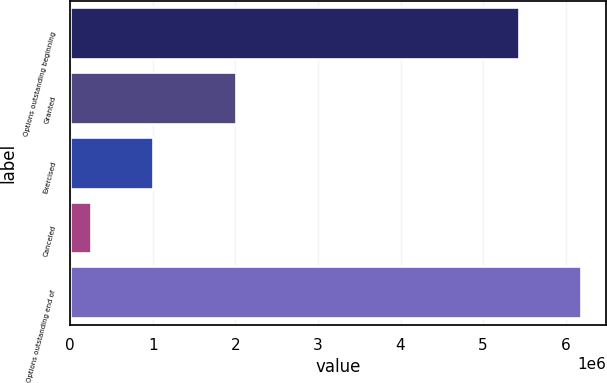Convert chart. <chart><loc_0><loc_0><loc_500><loc_500><bar_chart><fcel>Options outstanding beginning<fcel>Granted<fcel>Exercised<fcel>Canceled<fcel>Options outstanding end of<nl><fcel>5.43806e+06<fcel>2.0065e+06<fcel>1.0031e+06<fcel>258444<fcel>6.18302e+06<nl></chart> 